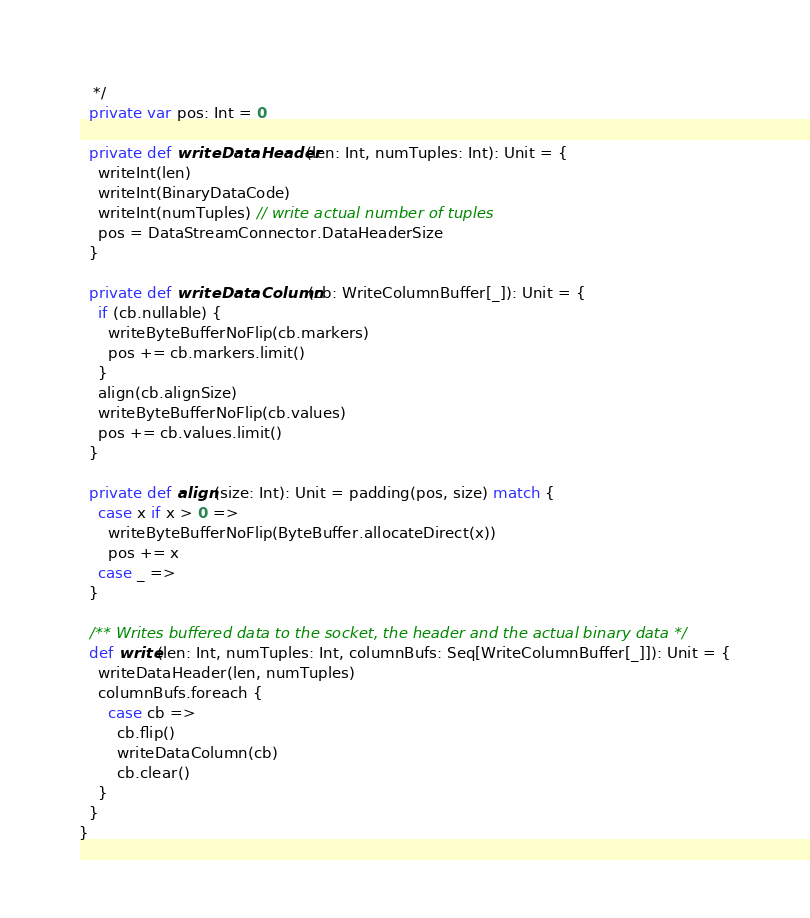<code> <loc_0><loc_0><loc_500><loc_500><_Scala_>   */
  private var pos: Int = 0

  private def writeDataHeader(len: Int, numTuples: Int): Unit = {
    writeInt(len)
    writeInt(BinaryDataCode)
    writeInt(numTuples) // write actual number of tuples
    pos = DataStreamConnector.DataHeaderSize
  }

  private def writeDataColumn(cb: WriteColumnBuffer[_]): Unit = {
    if (cb.nullable) {
      writeByteBufferNoFlip(cb.markers)
      pos += cb.markers.limit()
    }
    align(cb.alignSize)
    writeByteBufferNoFlip(cb.values)
    pos += cb.values.limit()
  }

  private def align(size: Int): Unit = padding(pos, size) match {
    case x if x > 0 =>
      writeByteBufferNoFlip(ByteBuffer.allocateDirect(x))
      pos += x
    case _ =>
  }

  /** Writes buffered data to the socket, the header and the actual binary data */
  def write(len: Int, numTuples: Int, columnBufs: Seq[WriteColumnBuffer[_]]): Unit = {
    writeDataHeader(len, numTuples)
    columnBufs.foreach {
      case cb =>
        cb.flip()
        writeDataColumn(cb)
        cb.clear()
    }
  }
}
</code> 